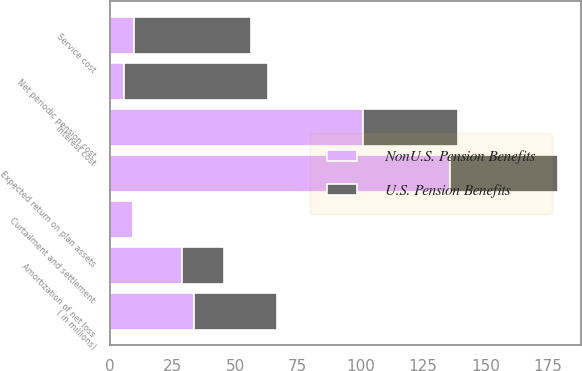Convert chart. <chart><loc_0><loc_0><loc_500><loc_500><stacked_bar_chart><ecel><fcel>( in millions)<fcel>Service cost<fcel>Interest cost<fcel>Expected return on plan assets<fcel>Amortization of net loss<fcel>Curtailment and settlement<fcel>Net periodic pension cost<nl><fcel>NonU.S. Pension Benefits<fcel>33.35<fcel>9.6<fcel>101.1<fcel>136<fcel>28.9<fcel>9.3<fcel>5.7<nl><fcel>U.S. Pension Benefits<fcel>33.35<fcel>46.8<fcel>37.8<fcel>43.1<fcel>16.6<fcel>0.4<fcel>57.5<nl></chart> 